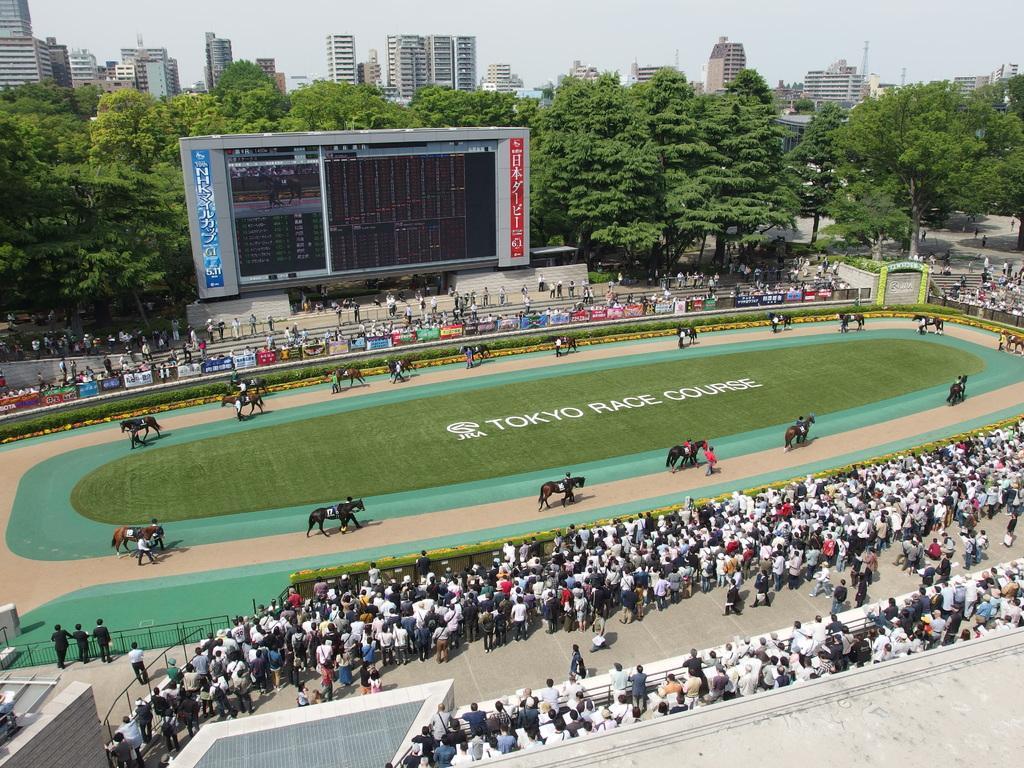Can you describe this image briefly? In the foreground of this image, there are group of people standing. In the background, there are horses and persons walking in a circular motion and we can also see persons, buildings, trees and the sky. 